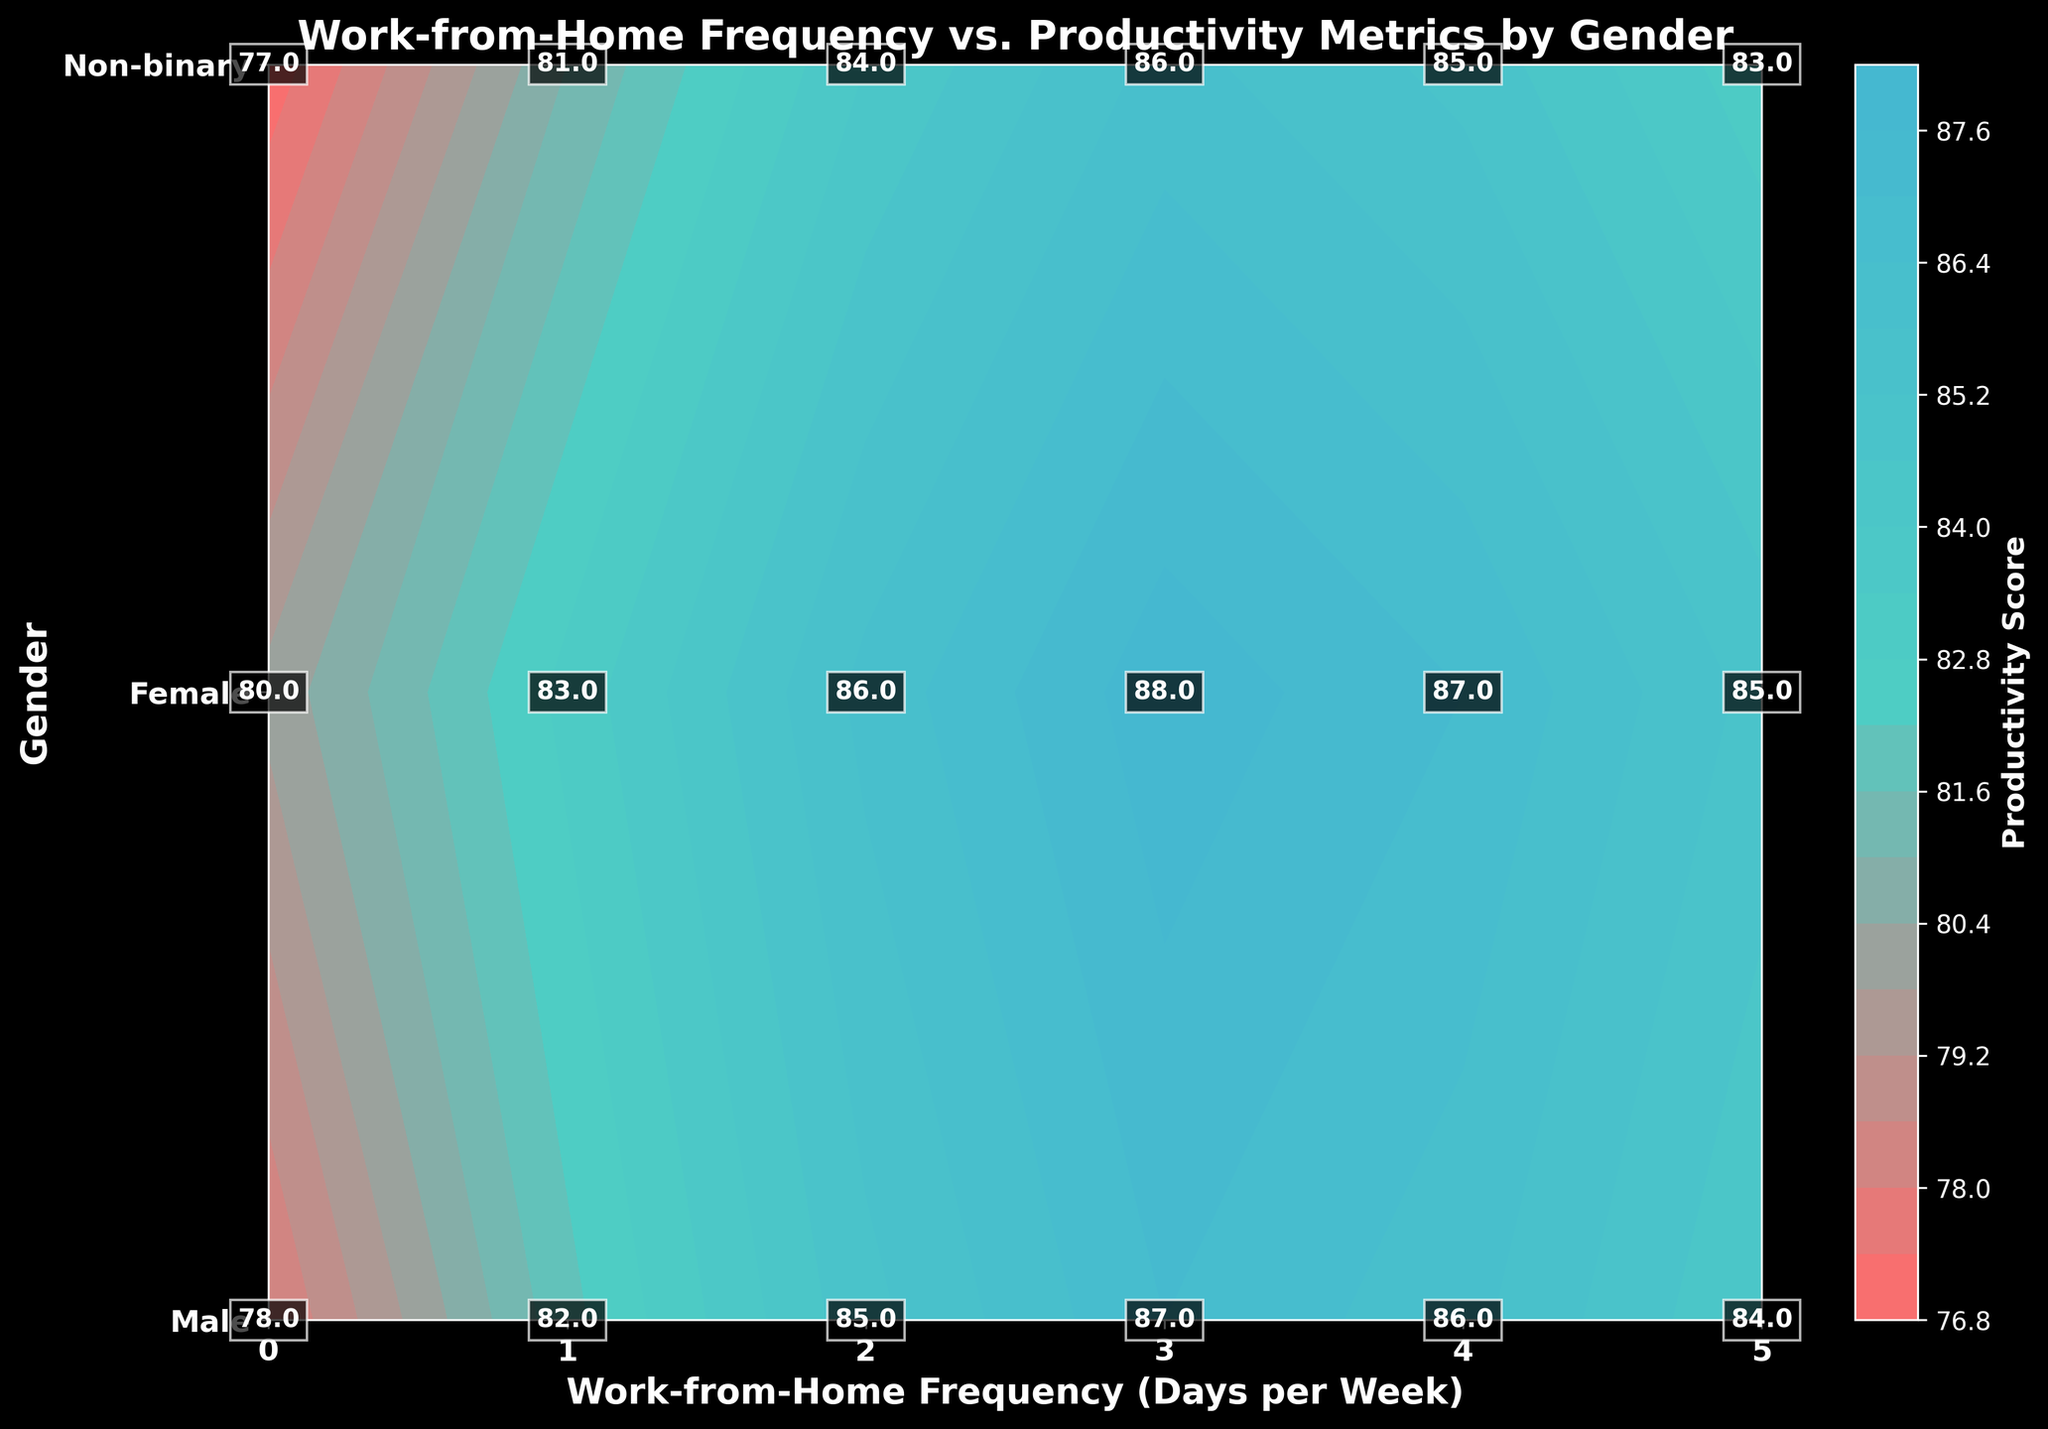How many genders are represented in the plot? The y-axis labels indicate the different genders. There are unique labels for "Male," "Female," and "Non-binary."
Answer: 3 What's the title of the plot? The title is displayed at the top of the plot.
Answer: Work-from-Home Frequency vs. Productivity Metrics by Gender Which gender has the highest productivity score when working from home 3 days per week? By looking at the values displayed on the contour plot at the intersection of "3 days per week" and each gender, "Female" has the highest productivity score of 88.
Answer: Female What is the average productivity score for males across all work-from-home frequencies? The productivity scores for males at 0 to 5 days per week are 78, 82, 85, 87, 86, 84. Sum these up to get 502, and then divide by 6: 502 / 6 = 83.67.
Answer: 83.67 Compare the productivity score of Female and Non-binary employees at 4 days per week. Which is higher? The contour plot shows that at 4 days per week, Female employees have a score of 87, and Non-binary employees have a score of 85.
Answer: Female What's the overall trend in productivity for Male employees as the work-from-home frequency increases? By observing the contour plot's values from 0 to 5 days, the productivity score increases from 78 to 87 at 3 days and then slightly decreases to 84 by 5 days.
Answer: Increases then slightly decreases What is the difference in productivity scores between Female and Male employees at 1 day per week? The productivity score for Female employees at 1 day per week is 83, while for Male employees it is 82. The difference is 83 - 82.
Answer: 1 At what work-from-home frequency do Non-binary employees have their highest productivity score? From the contour plot, the highest productivity score for Non-binary employees, 86, occurs at 3 days per week.
Answer: 3 days Is there any gender that has a decreasing trend in productivity scores as work-from-home frequency increases? By examining the trends for each gender, Male and Female both initially increase and then slightly decrease, but Non-binary employees consistently increase up to 3 days and then decrease.
Answer: No 